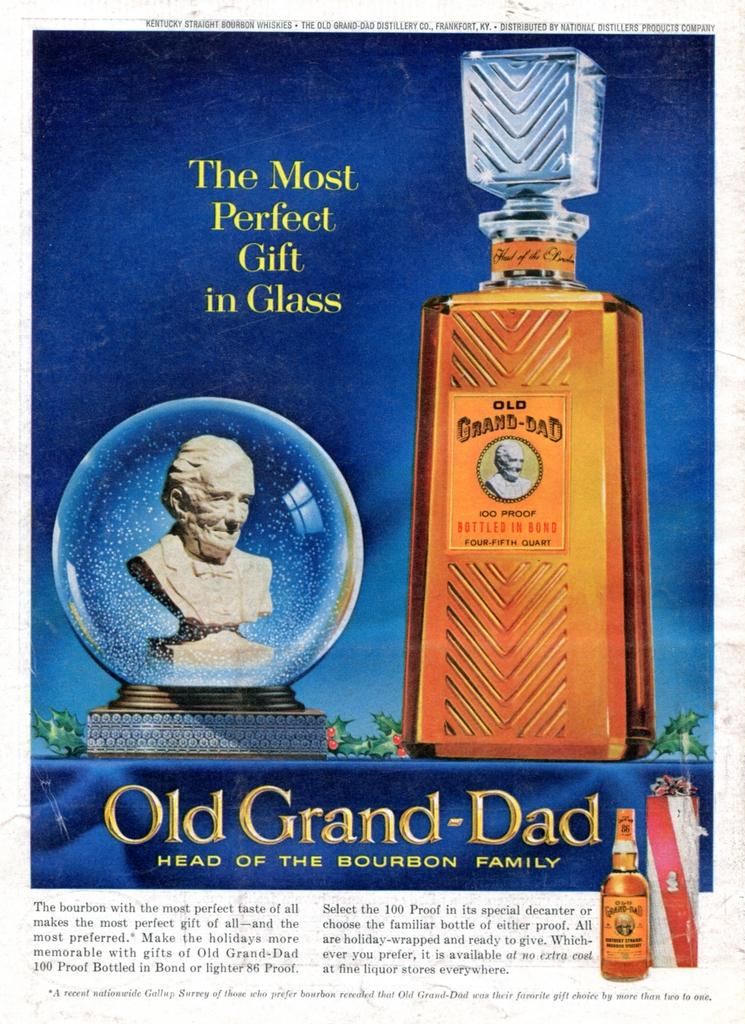<image>
Create a compact narrative representing the image presented. A magazine advertisement of a very fancy Bourbon and a head statue, 